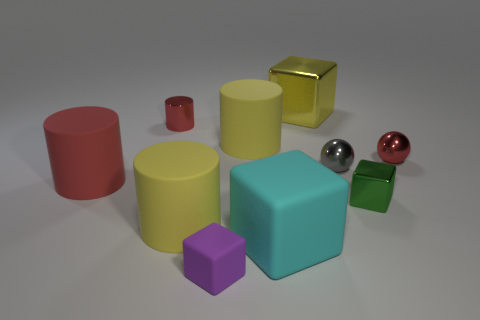What shape is the metallic object that is the same color as the small cylinder?
Your answer should be compact. Sphere. Are there any small balls of the same color as the metallic cylinder?
Offer a very short reply. Yes. There is another cylinder that is the same color as the small cylinder; what is its size?
Give a very brief answer. Large. How many big yellow objects are both behind the tiny green metallic cube and left of the cyan block?
Provide a succinct answer. 1. What is the color of the small cube behind the big yellow matte cylinder that is in front of the big yellow matte cylinder behind the tiny red metallic sphere?
Your response must be concise. Green. What number of other objects are the same shape as the red matte thing?
Ensure brevity in your answer.  3. Is there a big matte cylinder behind the red cylinder that is in front of the red shiny cylinder?
Keep it short and to the point. Yes. How many rubber things are either cubes or purple blocks?
Your answer should be compact. 2. There is a red thing that is to the left of the gray metallic thing and in front of the shiny cylinder; what is its material?
Offer a terse response. Rubber. Is there a block in front of the metallic cube in front of the tiny red metal thing that is to the right of the cyan matte object?
Provide a succinct answer. Yes. 